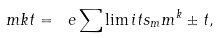Convert formula to latex. <formula><loc_0><loc_0><loc_500><loc_500>\ m k t = \ e \sum \lim i t s _ { m } m ^ { k } \pm t ,</formula> 